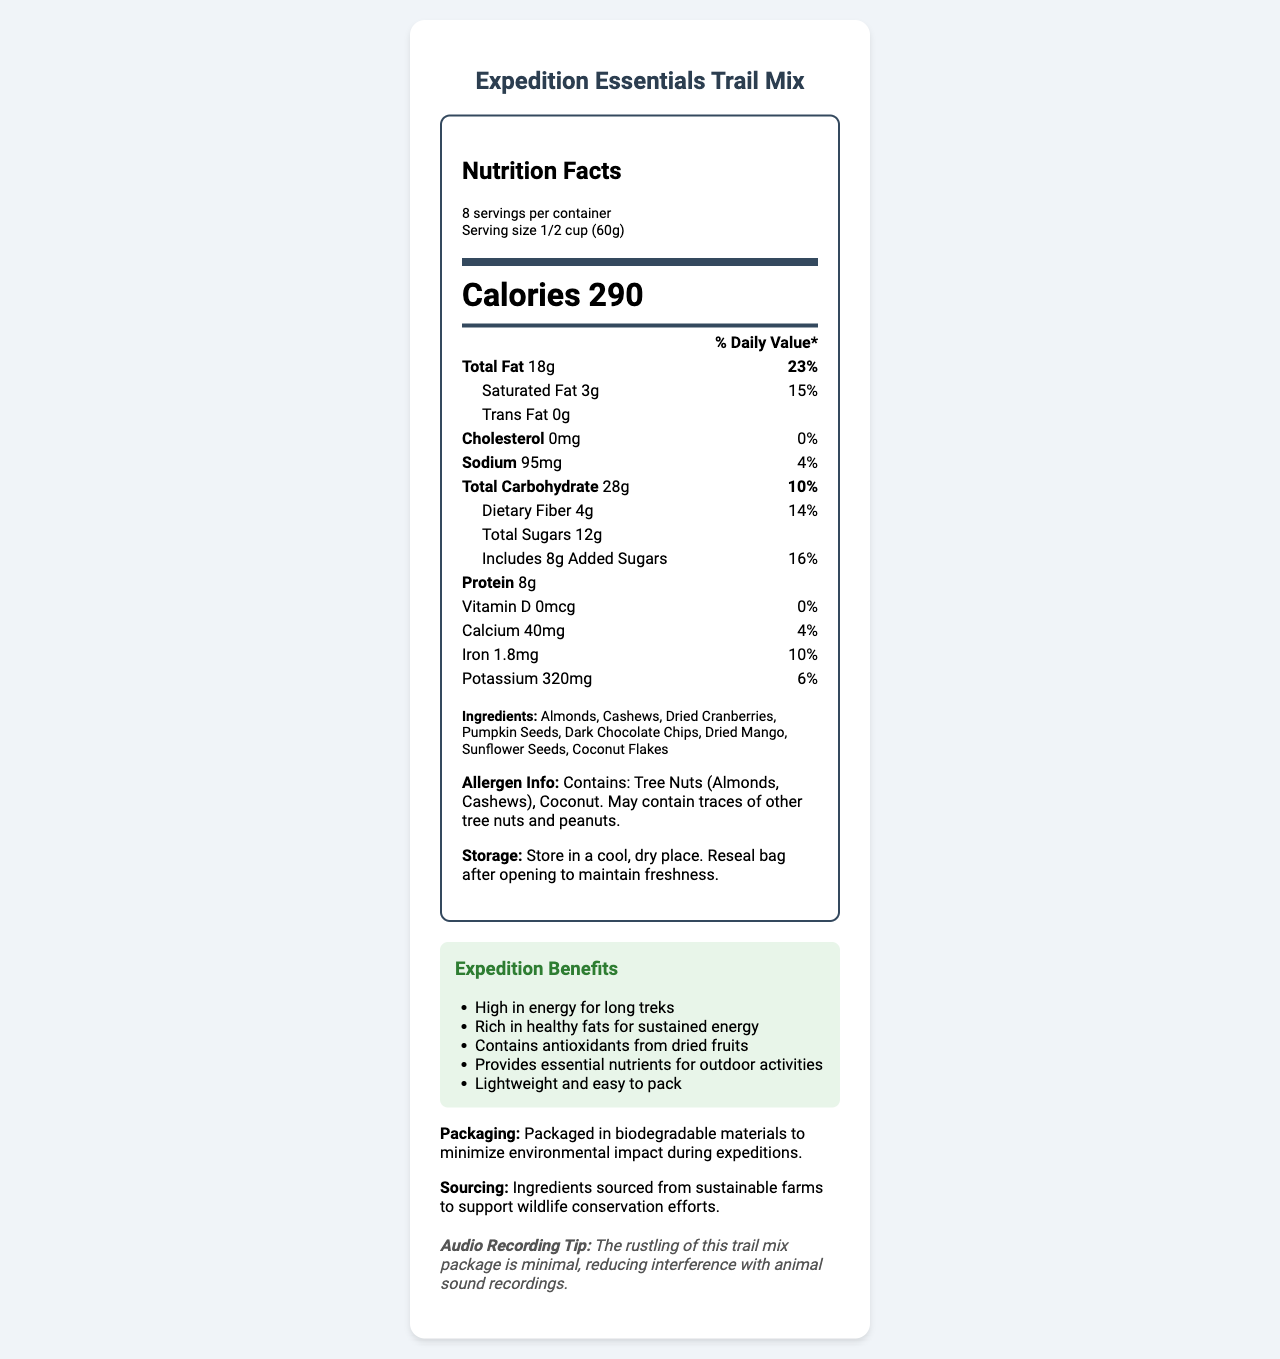What is the serving size for the Expedition Essentials Trail Mix? The serving size is clearly mentioned at the top of the nutrition label as "1/2 cup (60g)".
Answer: 1/2 cup (60g) How many calories are there per serving of the trail mix? The document lists "Calories 290" prominently in the nutrition facts section.
Answer: 290 List the two tree nuts mentioned in the allergen information. The allergen information states that the product contains tree nuts, specifically almonds and cashews.
Answer: Almonds, Cashews What percentage of the daily value for total fat does one serving provide? The "Total Fat" nutrient value shows 18g, which is 23% of the daily value.
Answer: 23% Which ingredient provides antioxidants according to the expedition benefits? The expedition benefits section mentions that the trail mix "Contains antioxidants from dried fruits".
Answer: Dried fruits What is the amount of protein per serving? The document lists the protein amount as "Protein 8g" within the nutrition facts label.
Answer: 8g Does the trail mix contain any cholesterol? The nutrition facts state "Cholesterol 0mg 0%", which means there is no cholesterol in the trail mix.
Answer: No Identify one benefit of the trail mix during expeditions. The expedition benefits section lists several benefits, one of which is that the trail mix is "High in energy for long treks".
Answer: High in energy for long treks How much dietary fiber does one serving of the trail mix contain? A. 1g B. 2g C. 4g D. 6g The document specifies "Dietary Fiber 4g 14%" under the nutrition facts.
Answer: C. 4g Which of the following is a serving suggestion for maintaining freshness? I. Refrigerate after opening II. Store in a cool, dry place III. Keep in a moisture-resistant container The storage instructions recommend to "Store in a cool, dry place" and to "Reseal bag after opening".
Answer: II. Store in a cool, dry place Is the packaging of the trail mix wildlife-friendly? The document states that the trail mix is "Packaged in biodegradable materials to minimize environmental impact during expeditions".
Answer: Yes Describe the main benefits and features of the Expedition Essentials Trail Mix. The summary includes key nutrition facts, ingredients, allergen info, and the benefits of the trail mix, emphasizing its suitability for outdoor activities and its environmentally friendly packaging.
Answer: The Expedition Essentials Trail Mix is designed for wildlife expeditions, providing high energy with 290 calories per serving. It is rich in healthy fats, contains no cholesterol, and provides essential nutrients like protein, fiber, and potassium. The mix offers various benefits like antioxidants from dried fruits and sustained energy from nuts and seeds. It's lightweight, easy to pack, and features wildlife-friendly biodegradable packaging. The product includes almonds, cashews, and coconut, and should be stored in a cool, dry place to maintain freshness. What is the manufacturing date of this trail mix product? The document does not provide any information about the manufacturing date, making it impossible to determine based on the visual information.
Answer: Cannot be determined 